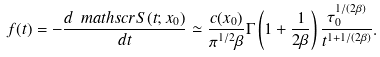Convert formula to latex. <formula><loc_0><loc_0><loc_500><loc_500>f ( t ) = - \frac { d \ m a t h s c r { S } ( t ; x _ { 0 } ) } { d t } \simeq \frac { c ( x _ { 0 } ) } { \pi ^ { 1 / 2 } \beta } \Gamma \left ( 1 + \frac { 1 } { 2 \beta } \right ) \frac { \tau _ { 0 } ^ { 1 / ( 2 \beta ) } } { t ^ { 1 + 1 / ( 2 \beta ) } } .</formula> 